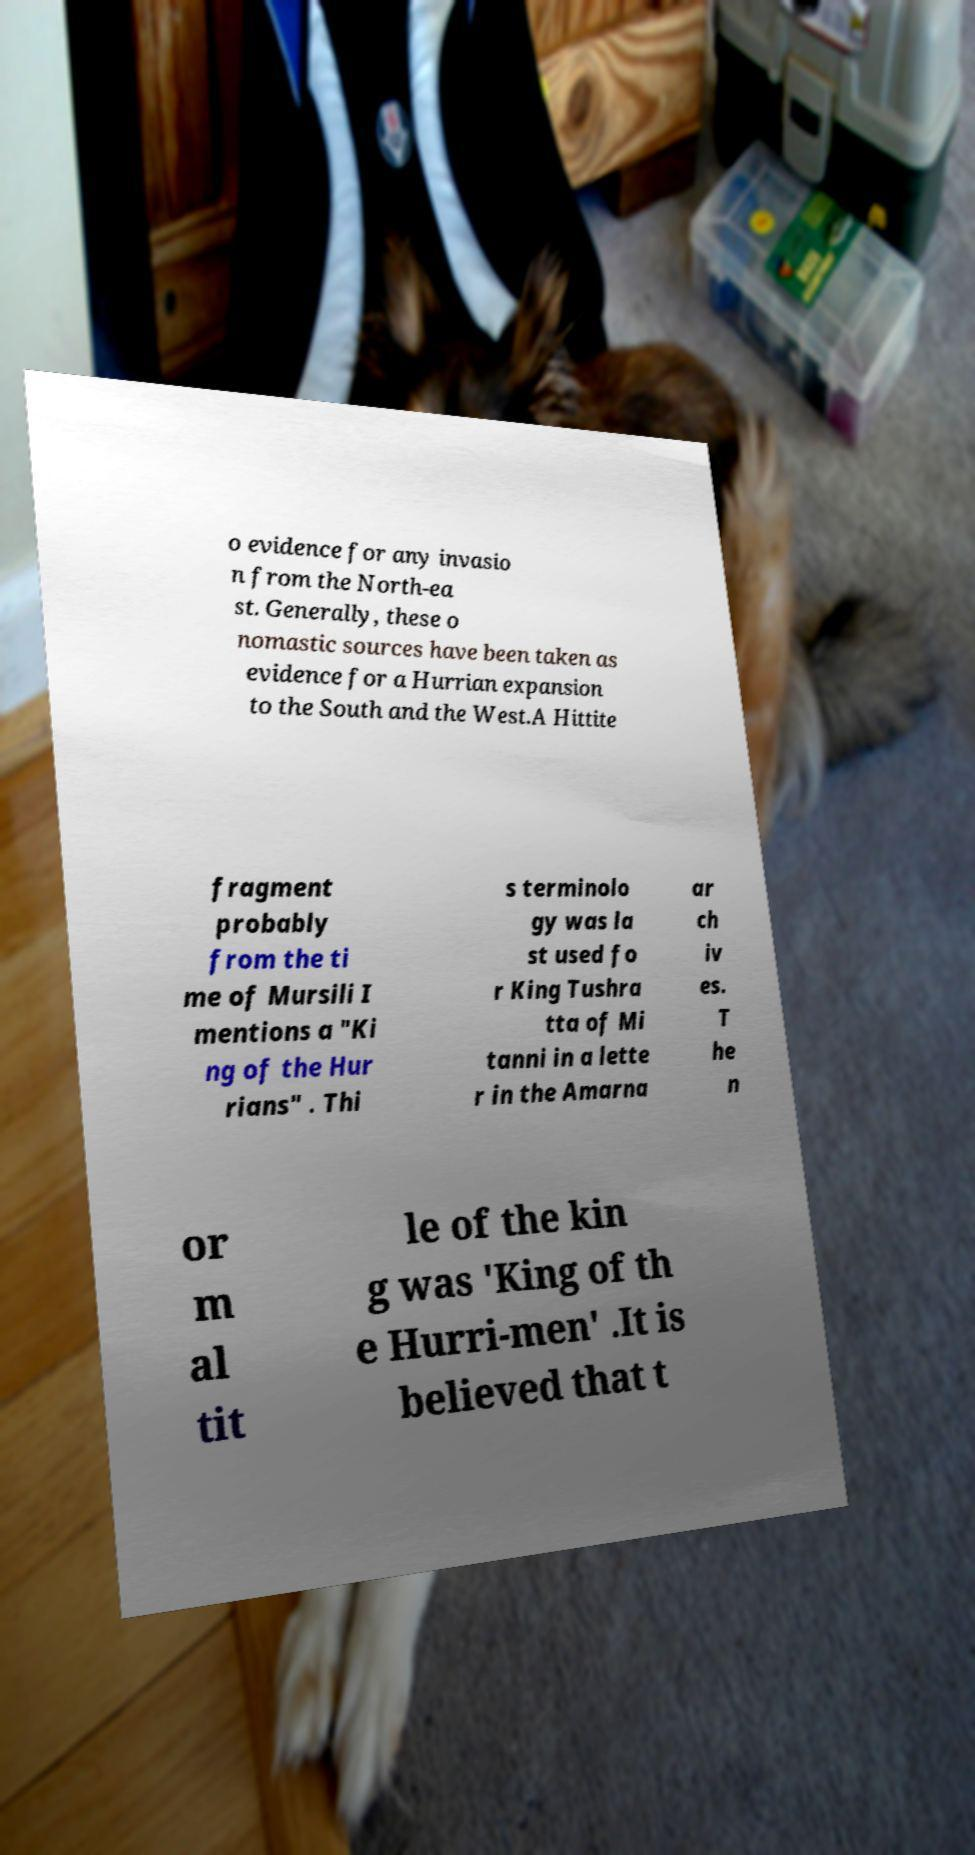There's text embedded in this image that I need extracted. Can you transcribe it verbatim? o evidence for any invasio n from the North-ea st. Generally, these o nomastic sources have been taken as evidence for a Hurrian expansion to the South and the West.A Hittite fragment probably from the ti me of Mursili I mentions a "Ki ng of the Hur rians" . Thi s terminolo gy was la st used fo r King Tushra tta of Mi tanni in a lette r in the Amarna ar ch iv es. T he n or m al tit le of the kin g was 'King of th e Hurri-men' .It is believed that t 